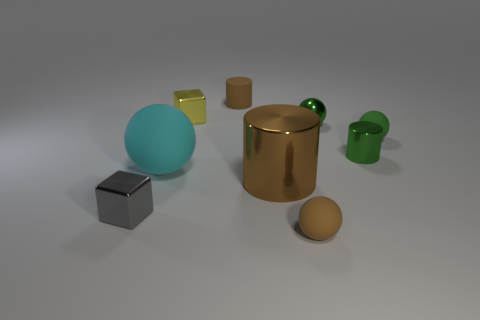Subtract 1 balls. How many balls are left? 3 Subtract all brown balls. How many balls are left? 3 Subtract all purple spheres. Subtract all cyan cylinders. How many spheres are left? 4 Subtract all cylinders. How many objects are left? 6 Add 8 small cubes. How many small cubes exist? 10 Subtract 0 blue spheres. How many objects are left? 9 Subtract all tiny gray blocks. Subtract all cyan matte objects. How many objects are left? 7 Add 1 tiny brown matte things. How many tiny brown matte things are left? 3 